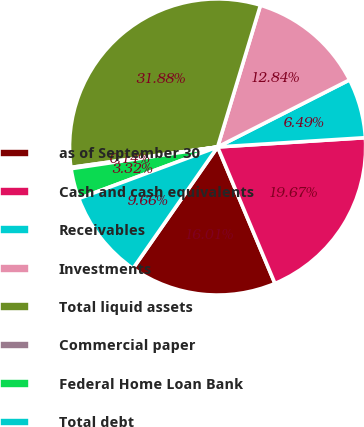Convert chart to OTSL. <chart><loc_0><loc_0><loc_500><loc_500><pie_chart><fcel>as of September 30<fcel>Cash and cash equivalents<fcel>Receivables<fcel>Investments<fcel>Total liquid assets<fcel>Commercial paper<fcel>Federal Home Loan Bank<fcel>Total debt<nl><fcel>16.01%<fcel>19.67%<fcel>6.49%<fcel>12.84%<fcel>31.88%<fcel>0.14%<fcel>3.32%<fcel>9.66%<nl></chart> 